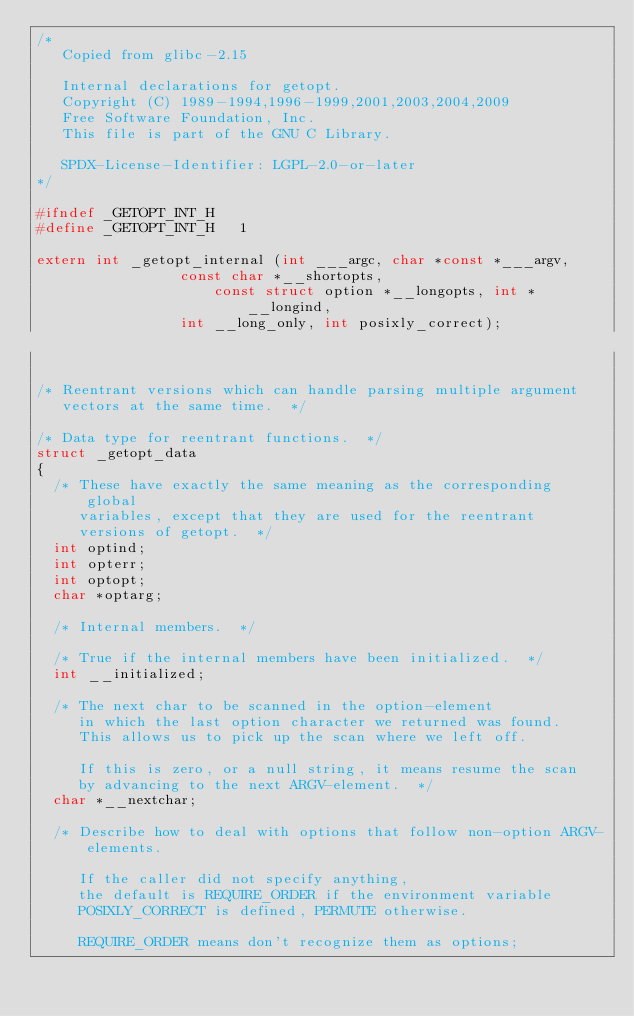<code> <loc_0><loc_0><loc_500><loc_500><_C_>/*
   Copied from glibc-2.15

   Internal declarations for getopt.
   Copyright (C) 1989-1994,1996-1999,2001,2003,2004,2009
   Free Software Foundation, Inc.
   This file is part of the GNU C Library.

   SPDX-License-Identifier: LGPL-2.0-or-later
*/

#ifndef _GETOPT_INT_H
#define _GETOPT_INT_H	1

extern int _getopt_internal (int ___argc, char *const *___argv,
			     const char *__shortopts,
		             const struct option *__longopts, int *__longind,
			     int __long_only, int posixly_correct);


/* Reentrant versions which can handle parsing multiple argument
   vectors at the same time.  */

/* Data type for reentrant functions.  */
struct _getopt_data
{
  /* These have exactly the same meaning as the corresponding global
     variables, except that they are used for the reentrant
     versions of getopt.  */
  int optind;
  int opterr;
  int optopt;
  char *optarg;

  /* Internal members.  */

  /* True if the internal members have been initialized.  */
  int __initialized;

  /* The next char to be scanned in the option-element
     in which the last option character we returned was found.
     This allows us to pick up the scan where we left off.

     If this is zero, or a null string, it means resume the scan
     by advancing to the next ARGV-element.  */
  char *__nextchar;

  /* Describe how to deal with options that follow non-option ARGV-elements.

     If the caller did not specify anything,
     the default is REQUIRE_ORDER if the environment variable
     POSIXLY_CORRECT is defined, PERMUTE otherwise.

     REQUIRE_ORDER means don't recognize them as options;</code> 